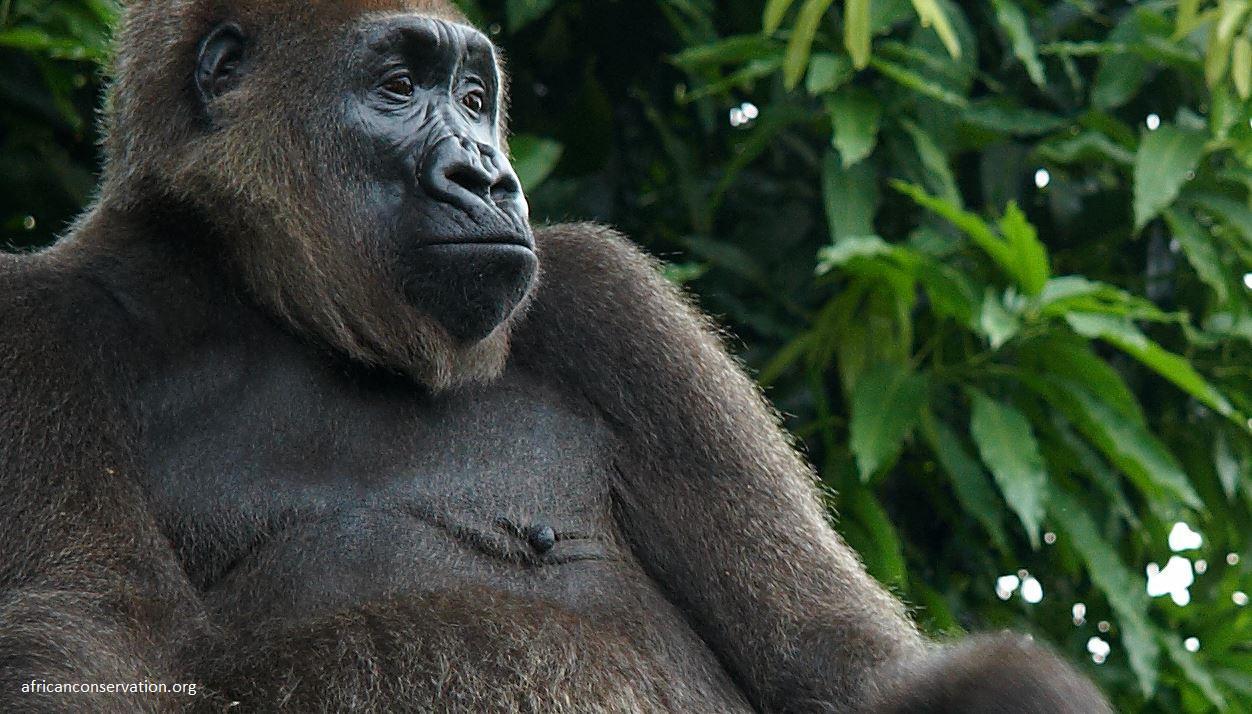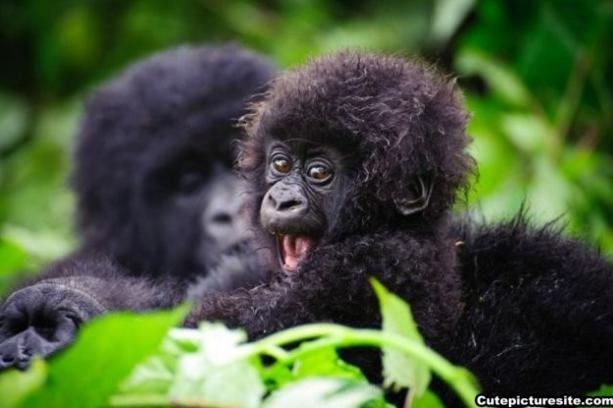The first image is the image on the left, the second image is the image on the right. Considering the images on both sides, is "Each image contains only one gorilla, and one image features an adult gorilla sitting with its body turned rightward and its head somewhat turned to look forward over its shoulder." valid? Answer yes or no. No. The first image is the image on the left, the second image is the image on the right. Considering the images on both sides, is "The primate in the image on the left is an adult, and there is at least one baby primate in the image on the right." valid? Answer yes or no. Yes. 